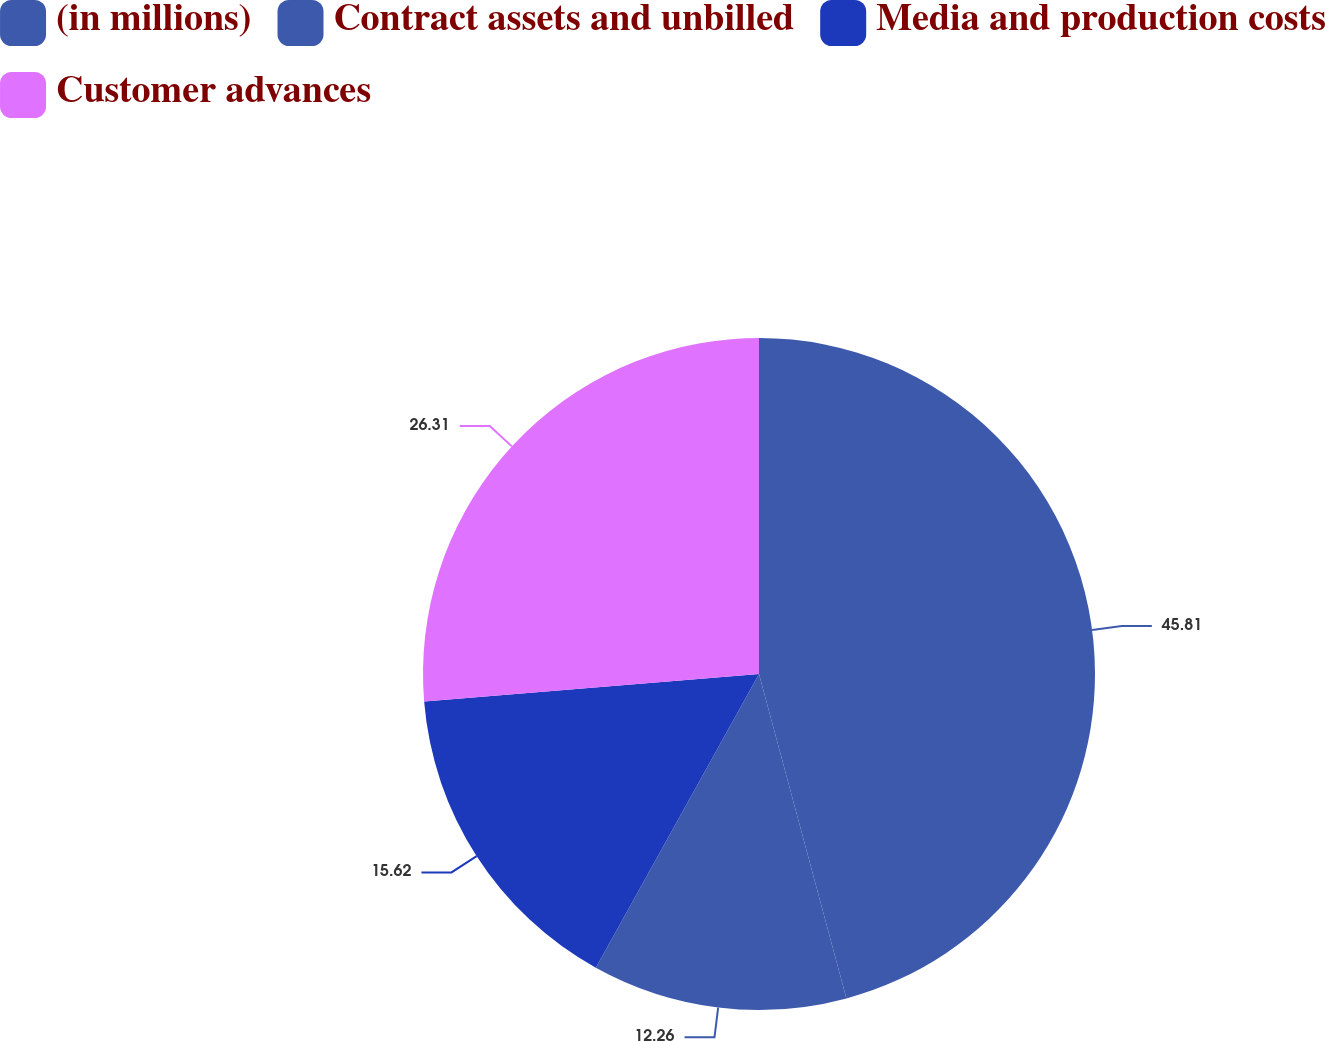Convert chart to OTSL. <chart><loc_0><loc_0><loc_500><loc_500><pie_chart><fcel>(in millions)<fcel>Contract assets and unbilled<fcel>Media and production costs<fcel>Customer advances<nl><fcel>45.81%<fcel>12.26%<fcel>15.62%<fcel>26.31%<nl></chart> 